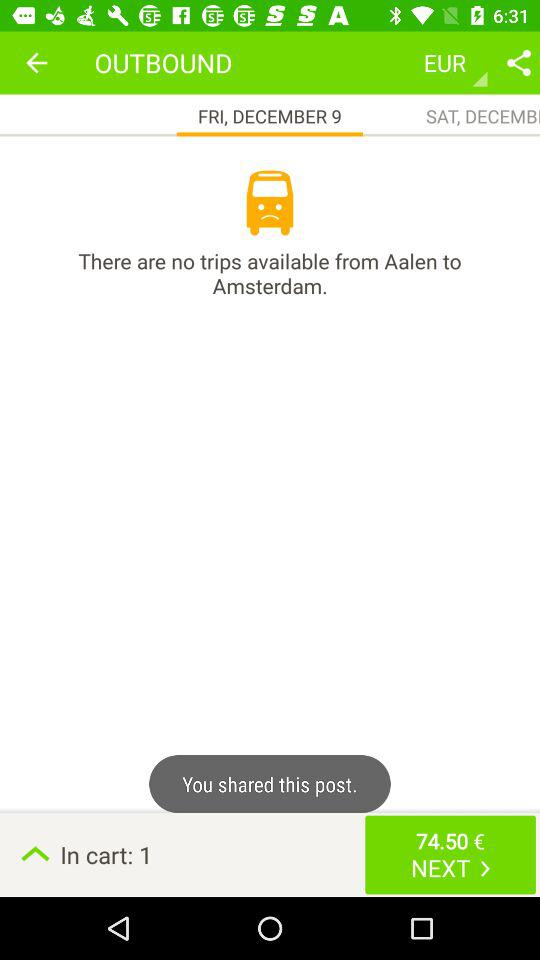What is the day for the outbound trip? The day is Friday. 